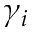Convert formula to latex. <formula><loc_0><loc_0><loc_500><loc_500>\gamma _ { i }</formula> 